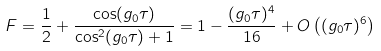Convert formula to latex. <formula><loc_0><loc_0><loc_500><loc_500>F = \frac { 1 } { 2 } + \frac { \cos ( g _ { 0 } \tau ) } { \cos ^ { 2 } ( g _ { 0 } \tau ) + 1 } = 1 - \frac { ( g _ { 0 } \tau ) ^ { 4 } } { 1 6 } + O \left ( ( g _ { 0 } \tau ) ^ { 6 } \right )</formula> 